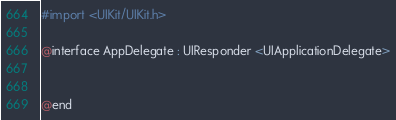Convert code to text. <code><loc_0><loc_0><loc_500><loc_500><_C_>#import <UIKit/UIKit.h>

@interface AppDelegate : UIResponder <UIApplicationDelegate>


@end

</code> 